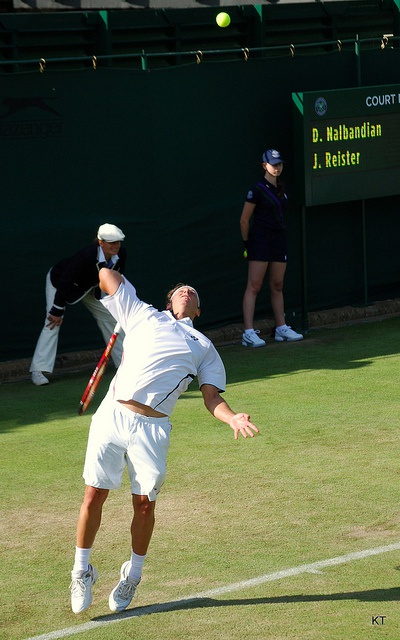Describe the objects in this image and their specific colors. I can see people in black, white, darkgray, and maroon tones, people in black and gray tones, people in black, gray, and darkgray tones, tennis racket in black, maroon, gray, and white tones, and sports ball in black, khaki, olive, lime, and yellow tones in this image. 